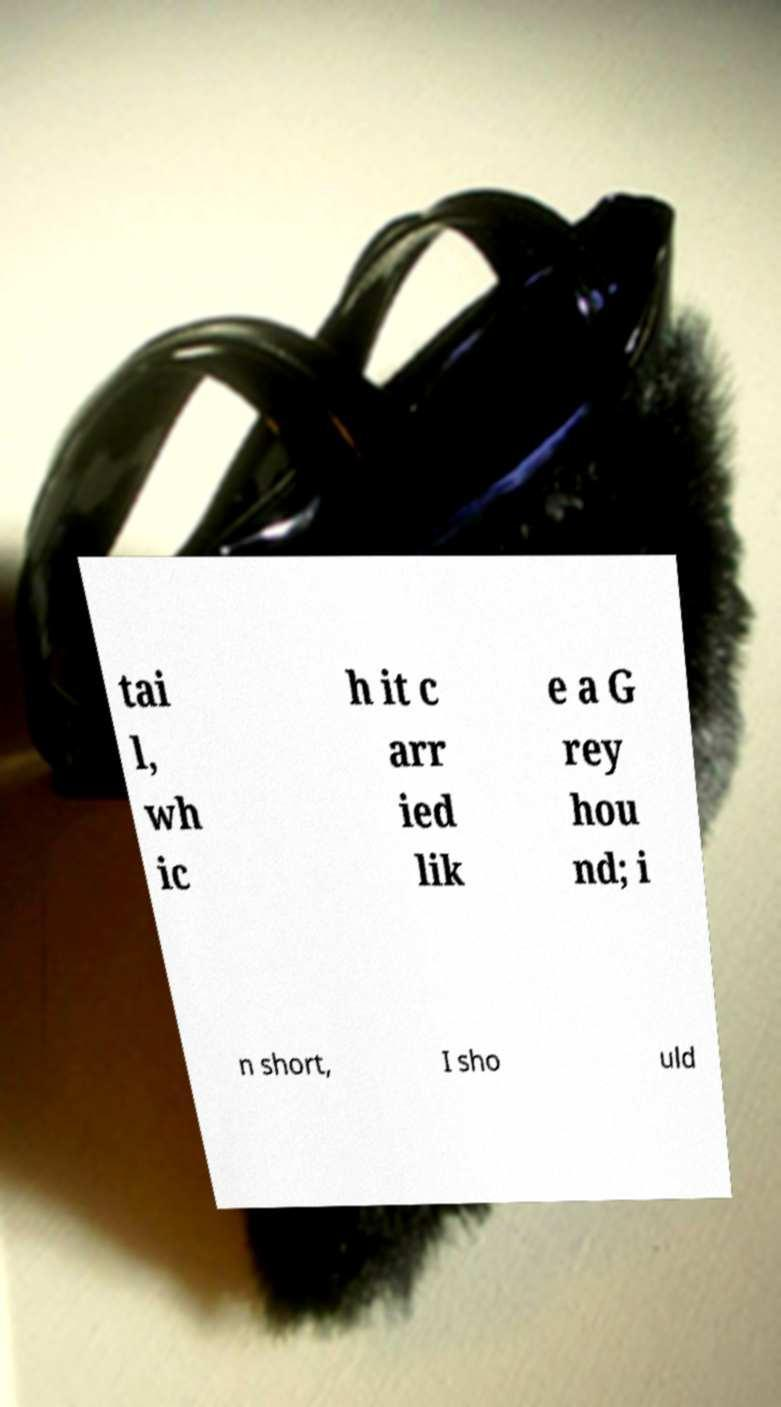Can you read and provide the text displayed in the image?This photo seems to have some interesting text. Can you extract and type it out for me? tai l, wh ic h it c arr ied lik e a G rey hou nd; i n short, I sho uld 